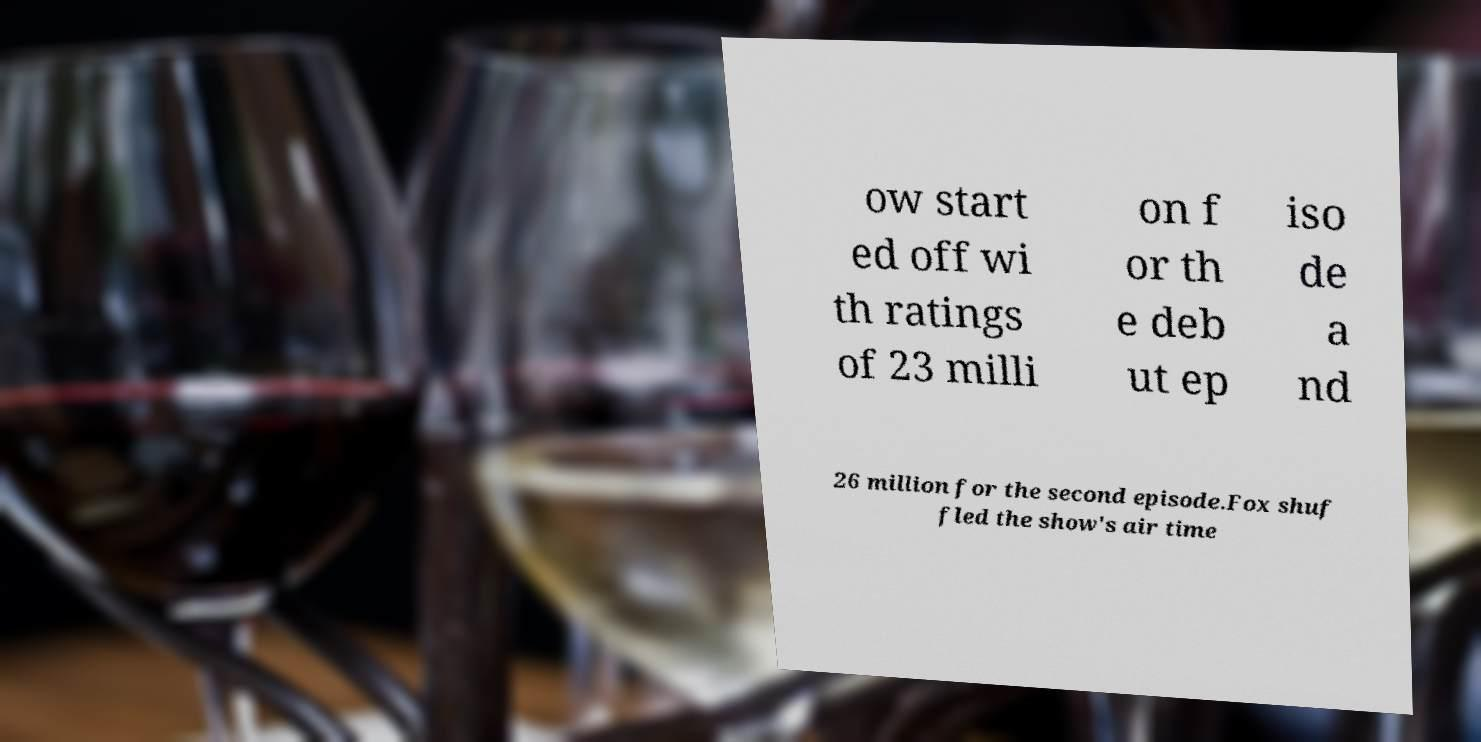Can you accurately transcribe the text from the provided image for me? ow start ed off wi th ratings of 23 milli on f or th e deb ut ep iso de a nd 26 million for the second episode.Fox shuf fled the show's air time 